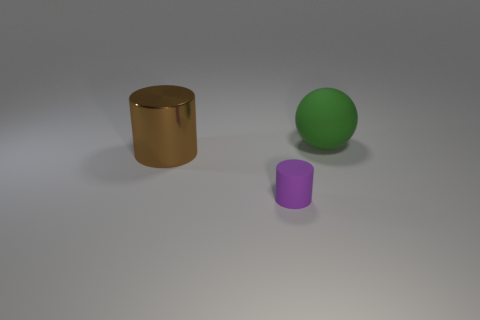What number of other things are the same color as the large metal thing?
Your answer should be very brief. 0. Are there fewer large green spheres right of the big cylinder than shiny objects?
Your answer should be very brief. No. What number of balls are there?
Offer a very short reply. 1. What number of large green things have the same material as the large brown object?
Your answer should be compact. 0. What number of things are either objects left of the large ball or large objects?
Offer a very short reply. 3. Is the number of purple matte objects that are in front of the brown object less than the number of things that are left of the big rubber ball?
Your response must be concise. Yes. Are there any objects on the right side of the tiny purple matte cylinder?
Offer a terse response. Yes. How many things are matte things that are behind the purple rubber thing or objects left of the large sphere?
Give a very brief answer. 3. What number of rubber objects are the same color as the rubber cylinder?
Make the answer very short. 0. The big shiny object that is the same shape as the purple rubber object is what color?
Your answer should be compact. Brown. 